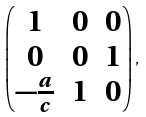<formula> <loc_0><loc_0><loc_500><loc_500>\left ( \begin{matrix} 1 & 0 & 0 \\ 0 & 0 & 1 \\ - \frac { a } { c } & 1 & 0 \end{matrix} \right ) ,</formula> 